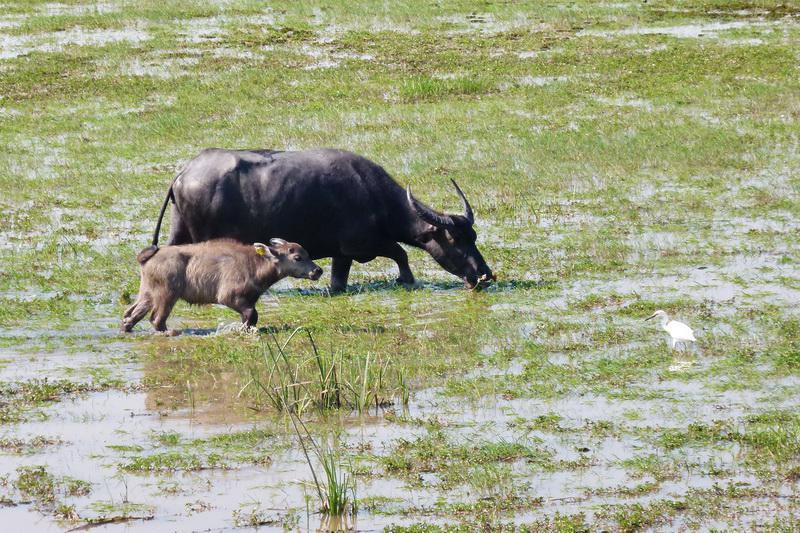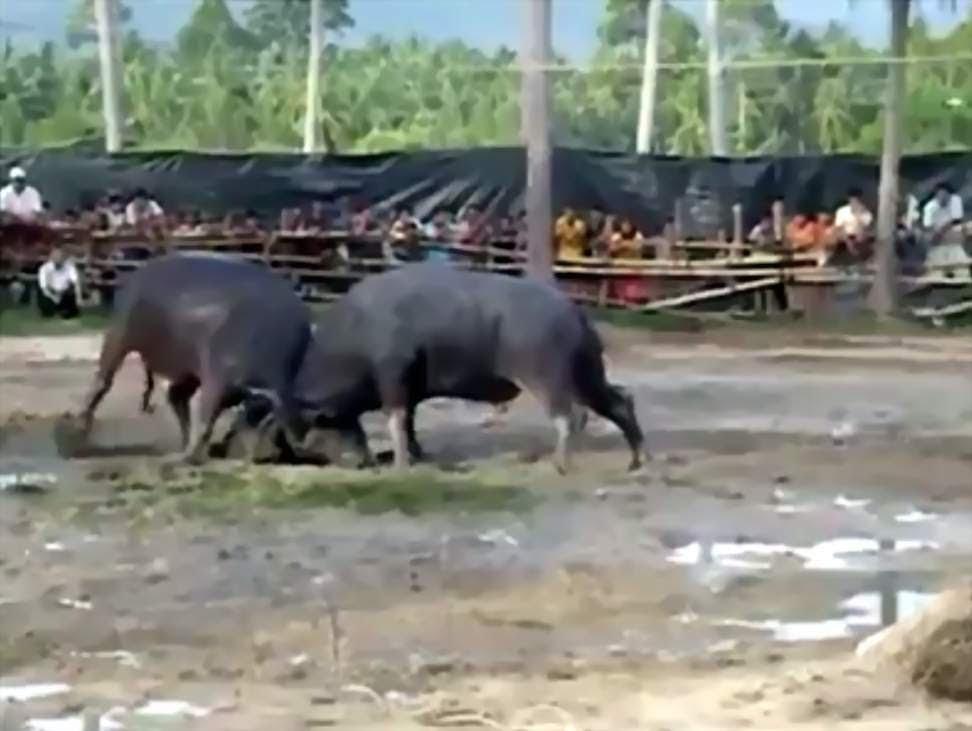The first image is the image on the left, the second image is the image on the right. Evaluate the accuracy of this statement regarding the images: "The left image contains at least two water buffalo.". Is it true? Answer yes or no. Yes. The first image is the image on the left, the second image is the image on the right. Assess this claim about the two images: "In each image, a rope can be seen threaded through the nose of at least one ox-like animal.". Correct or not? Answer yes or no. No. 